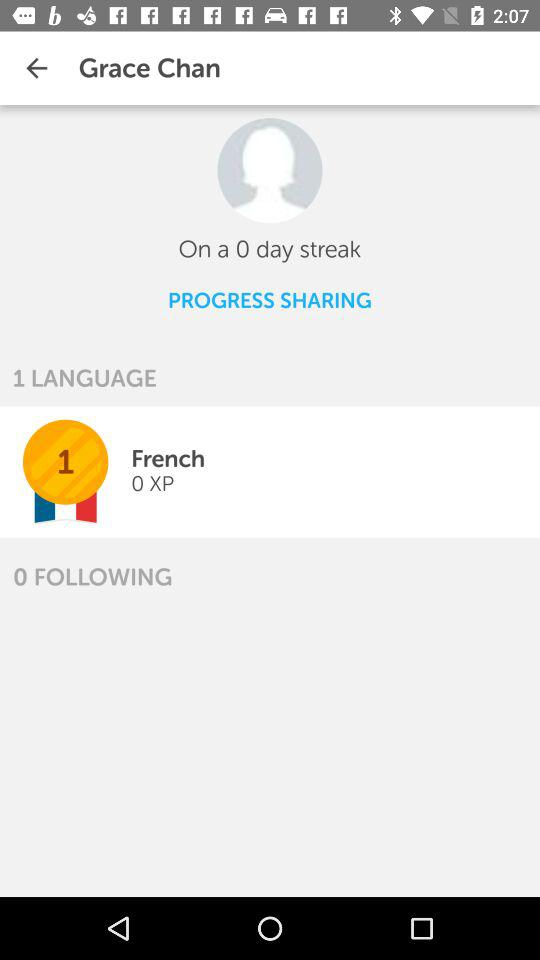How many more languages does Grace Chan know than she's following?
Answer the question using a single word or phrase. 1 